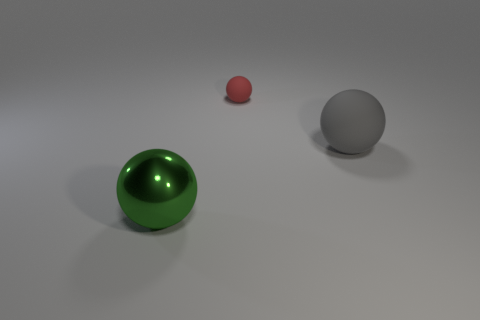Is there any other thing that is the same size as the red matte ball?
Ensure brevity in your answer.  No. What size is the red matte thing that is the same shape as the green thing?
Your answer should be very brief. Small. The green thing is what size?
Ensure brevity in your answer.  Large. Are there more metallic spheres that are behind the large green shiny thing than tiny cyan cylinders?
Keep it short and to the point. No. Is there anything else that has the same material as the big green thing?
Provide a short and direct response. No. There is a object right of the tiny red object; does it have the same color as the sphere that is to the left of the small object?
Your answer should be very brief. No. There is a large sphere behind the large ball on the left side of the big ball that is behind the large metallic thing; what is its material?
Provide a succinct answer. Rubber. Are there more rubber spheres than big cyan cylinders?
Your answer should be very brief. Yes. Are there any other things that have the same color as the big rubber object?
Offer a terse response. No. What is the size of the other ball that is made of the same material as the tiny sphere?
Offer a very short reply. Large. 